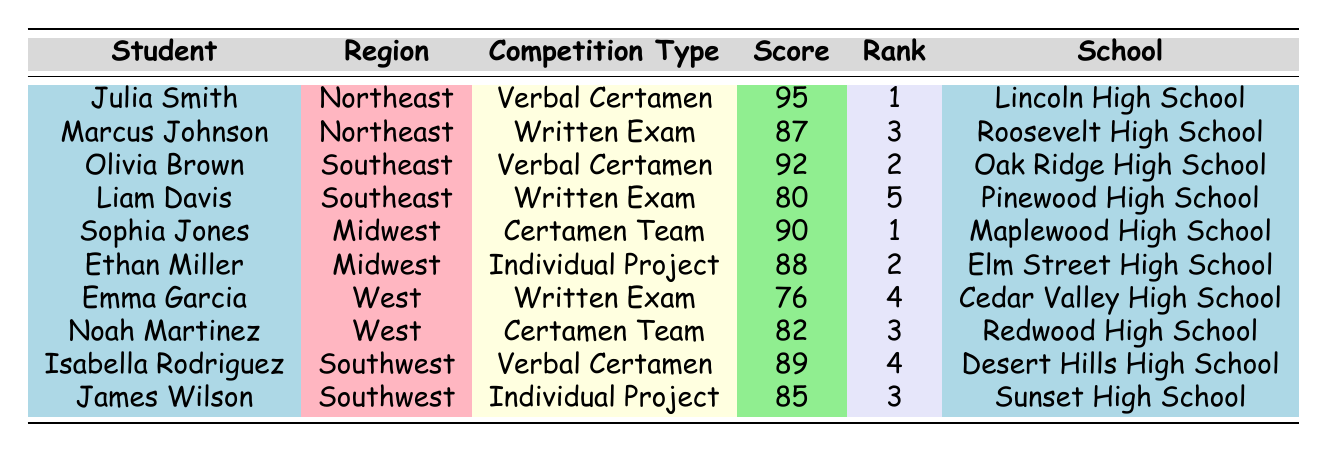What is the highest score achieved by a student in the table? By examining the "Score" column, the highest value is 95, belonging to Julia Smith.
Answer: 95 Which student from the Southeast region achieved the second rank? In the Southeast region, Olivia Brown has a score of 92 and is ranked 2.
Answer: Olivia Brown Is Noah Martinez from the West region ranked higher than Marcus Johnson from the Northeast region? Noah Martinez is ranked 3, while Marcus Johnson is ranked 3 as well, so they have the same rank.
Answer: No What is the average score of students participating in Verbal Certamen? The scores for the Verbal Certamen participants are 95, 92, and 89, so the average is (95 + 92 + 89) / 3 = 92.
Answer: 92 How many students have a score above 85? The students with scores above 85 are Julia Smith (95), Olivia Brown (92), Sophia Jones (90), Ethan Miller (88), and Isabella Rodriguez (89), totaling 5 students.
Answer: 5 Is Emma Garcia the lowest-ranked student in the table? Emma Garcia has a rank of 4, but Liam Davis has a rank of 5, making Emma not the lowest.
Answer: No What is the total score of students from the Midwest region? The scores for the Midwest region are 90 (Sophia Jones) and 88 (Ethan Miller). The total is 90 + 88 = 178.
Answer: 178 Which competition type has the most participants from the data provided? There are three instances of the "Written Exam" and two instances of the "Verbal Certamen," making "Written Exam" the most frequent competition type.
Answer: Written Exam Which school has the highest-ranking student based on the data? The highest rank is 1, with Julia Smith (Lincoln High School) and Sophia Jones (Maplewood High School) both achieving this rank.
Answer: Lincoln High School and Maplewood High School 